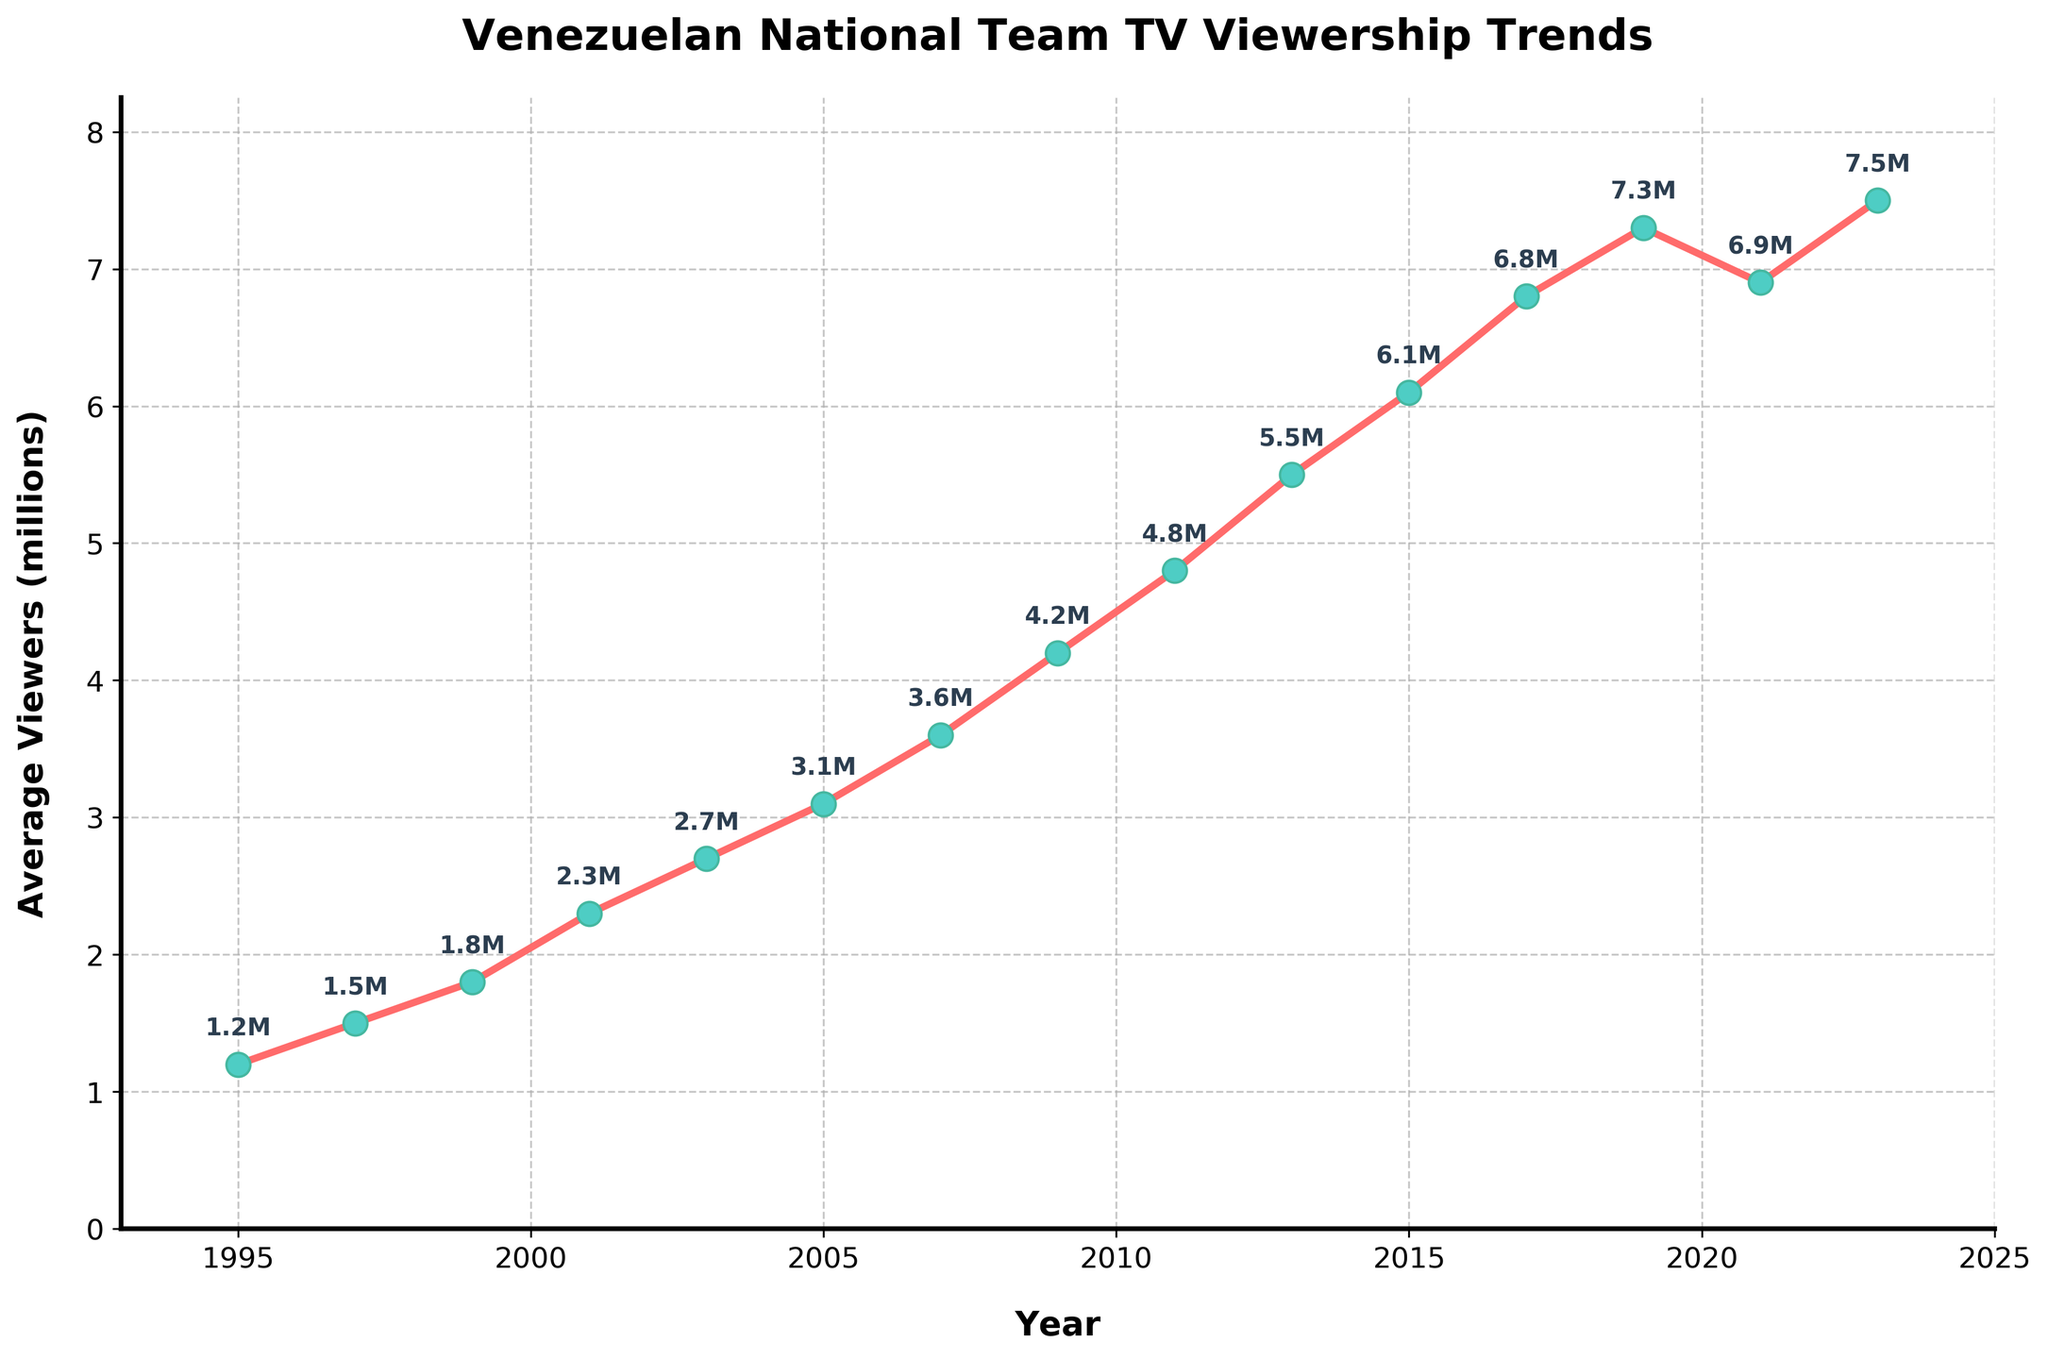What is the average viewership in 2007? First, locate the data point corresponding to 2007 on the x-axis, then refer to the y-axis to get the viewership value.
Answer: 3.6 million Which year had the highest viewership? Look along the x-axis for the highest y-axis point indicating viewership. The year is annotated next to the peak.
Answer: 2023 What is the difference in average viewership between 2019 and 2021? Identify the viewership values for 2019 (7.3 million) and 2021 (6.9 million). Subtract the 2021 value from the 2019 value.
Answer: 0.4 million Between which consecutive years is the largest increase in viewership observed? Compare the differences between the viewership values of consecutive years and identify the largest increase. The biggest increase occurs from 2011 (4.8 million) to 2013 (5.5 million).
Answer: 2011 and 2013 How many times does the viewership exceed 6 million? Count the data points where the viewership values are above 6 million on the y-axis. These years are 2015, 2017, 2019, 2021, and 2023.
Answer: 5 times Is there any year where the viewership decreased compared to the previous year? Check for any year where the viewership value is less than the previous year's value. This occurred between 2019 (7.3 million) and 2021 (6.9 million).
Answer: Yes, in 2021 In what year does the viewership first exceed 4 million? Identify the first data point where the y-axis value surpasses 4 million. This occurs in 2009.
Answer: 2009 What was the trend in viewership from 1995 to 2009? Examine the data points from 1995 to 2009 to observe the trend. The viewership steadily increased in this period.
Answer: Steady increase What is the percentage increase in average viewership from 1995 to 2023? Calculate the increase: (7.5 million - 1.2 million). Then, divide by the initial value (1.2 million) and multiply by 100 to get the percentage increase. (7.5 - 1.2) / 1.2 * 100 = 525%
Answer: 525% What is the average viewership over the entire period? Sum the viewership values for all years and divide by the number of years (15). (1.2 + 1.5 + 1.8 + 2.3 + 2.7 + 3.1 + 3.6 + 4.2 + 4.8 + 5.5 + 6.1 + 6.8 + 7.3 + 6.9 + 7.5) / 15 = 4.36 million
Answer: 4.36 million 